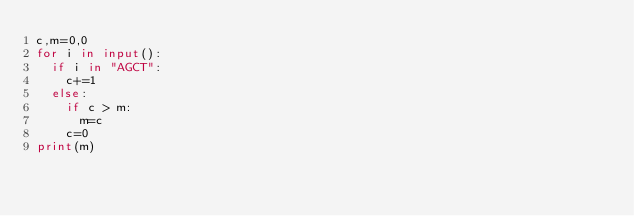Convert code to text. <code><loc_0><loc_0><loc_500><loc_500><_Python_>c,m=0,0
for i in input():
  if i in "AGCT":
    c+=1
  else:
    if c > m:
      m=c
    c=0
print(m)</code> 